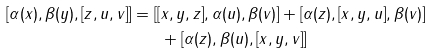<formula> <loc_0><loc_0><loc_500><loc_500>[ \alpha ( x ) , \beta ( y ) , [ z , u , v ] ] = [ [ & x , y , z ] , \alpha ( u ) , \beta ( v ) ] + [ \alpha ( z ) , [ x , y , u ] , \beta ( v ) ] \\ & + [ \alpha ( z ) , \beta ( u ) , [ x , y , v ] ]</formula> 